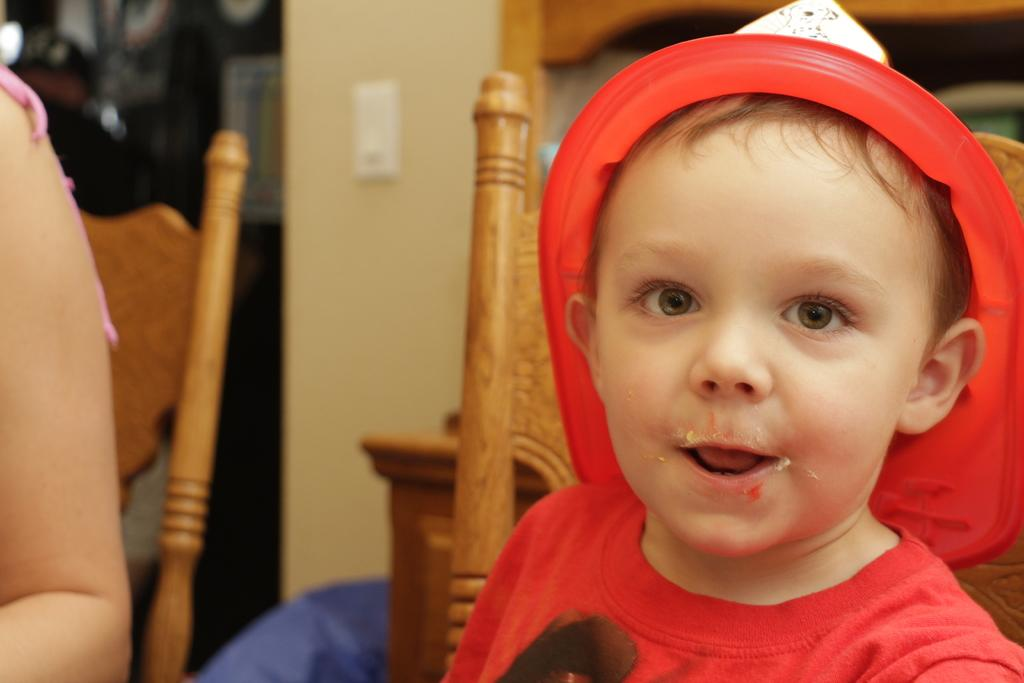Who is present in the image? There is a child in the image. What is the child's expression? The child is smiling. Whose hand is visible in the image? A person's hand is visible in the image. What can be seen in the background of the image? There are chairs, a wall, and some objects in the background of the image. How many sheep are visible in the image? There are no sheep present in the image. What type of beast is interacting with the child in the image? There is no beast present in the image; only the child and a person's hand are visible. 